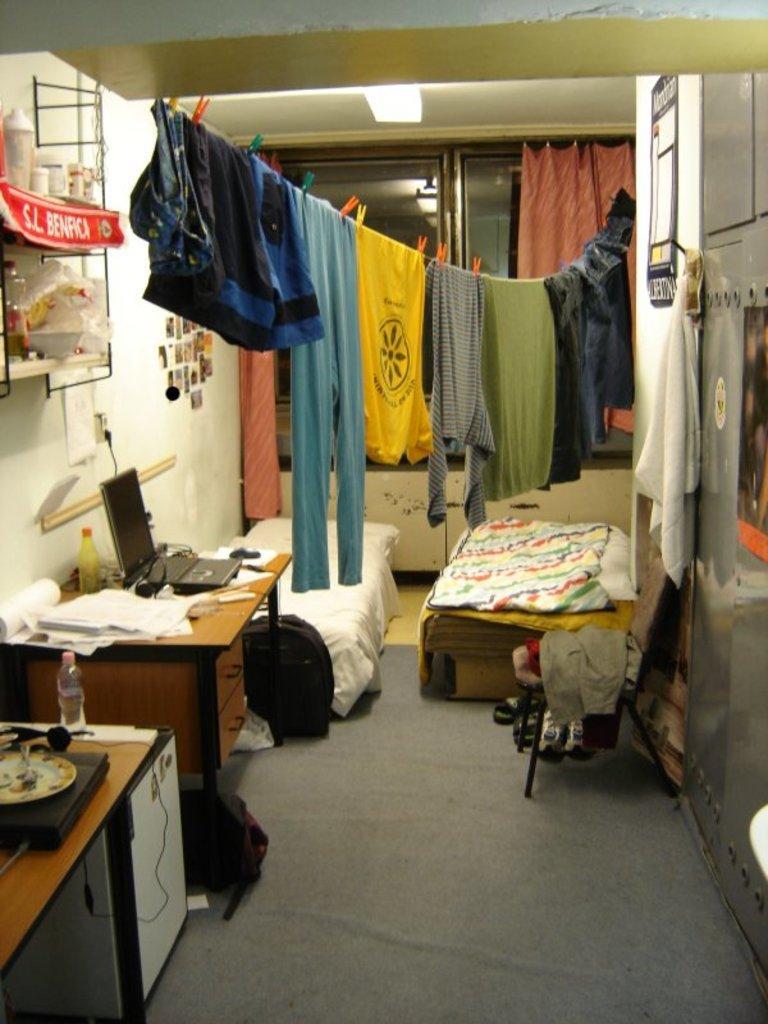In one or two sentences, can you explain what this image depicts? The picture contains of there are inside the room there are so many furniture are there and so many clothes are there and on the table there are some papers,laptop,bottle. 